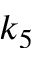Convert formula to latex. <formula><loc_0><loc_0><loc_500><loc_500>k _ { 5 }</formula> 